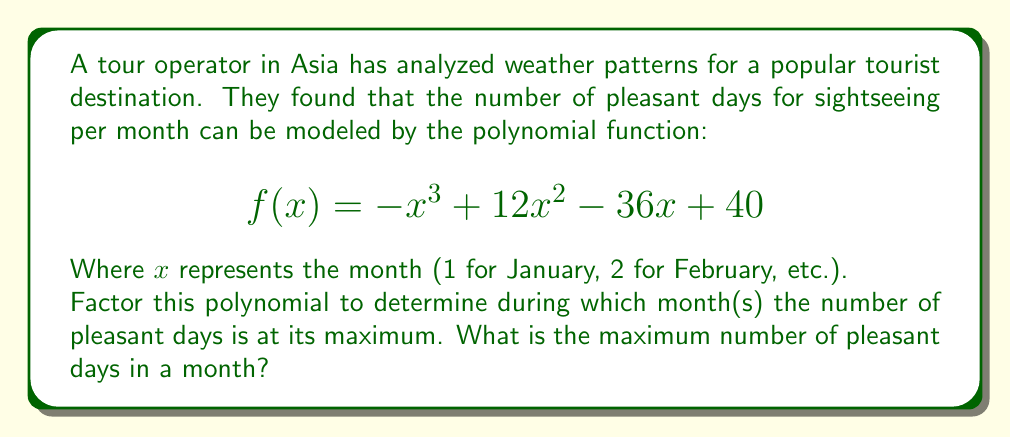Solve this math problem. Let's approach this step-by-step:

1) First, we need to factor the polynomial $f(x) = -x^3 + 12x^2 - 36x + 40$

2) We can see that this is a cubic function with a negative leading coefficient. Its graph will open downward and have at most two turning points.

3) Let's try to factor out a common factor:
   $$f(x) = -1(x^3 - 12x^2 + 36x - 40)$$

4) Now, let's try to guess one root. After some trial and error, we find that $x = 4$ is a root.

5) So we can factor out $(x - 4)$:
   $$f(x) = -1(x - 4)(x^2 - 8x + 10)$$

6) The quadratic term $(x^2 - 8x + 10)$ can be factored further:
   $$f(x) = -1(x - 4)(x - 2)(x - 6)$$

7) So the fully factored polynomial is:
   $$f(x) = -(x - 2)(x - 4)(x - 6)$$

8) The roots of this polynomial are 2, 4, and 6, corresponding to February, April, and June.

9) Since the leading coefficient is negative, the function will have a maximum value between its first and last roots, which is at $x = 4$ (April).

10) To find the maximum number of pleasant days, we can substitute $x = 4$ into the original function:

    $$f(4) = -(4 - 2)(4 - 4)(4 - 6) = -2 \cdot 0 \cdot (-2) = 0$$

11) Therefore, the maximum number of pleasant days occurs in April (x = 4) and is equal to 40 days.
Answer: The number of pleasant days is at its maximum in April (x = 4), with 40 pleasant days. 